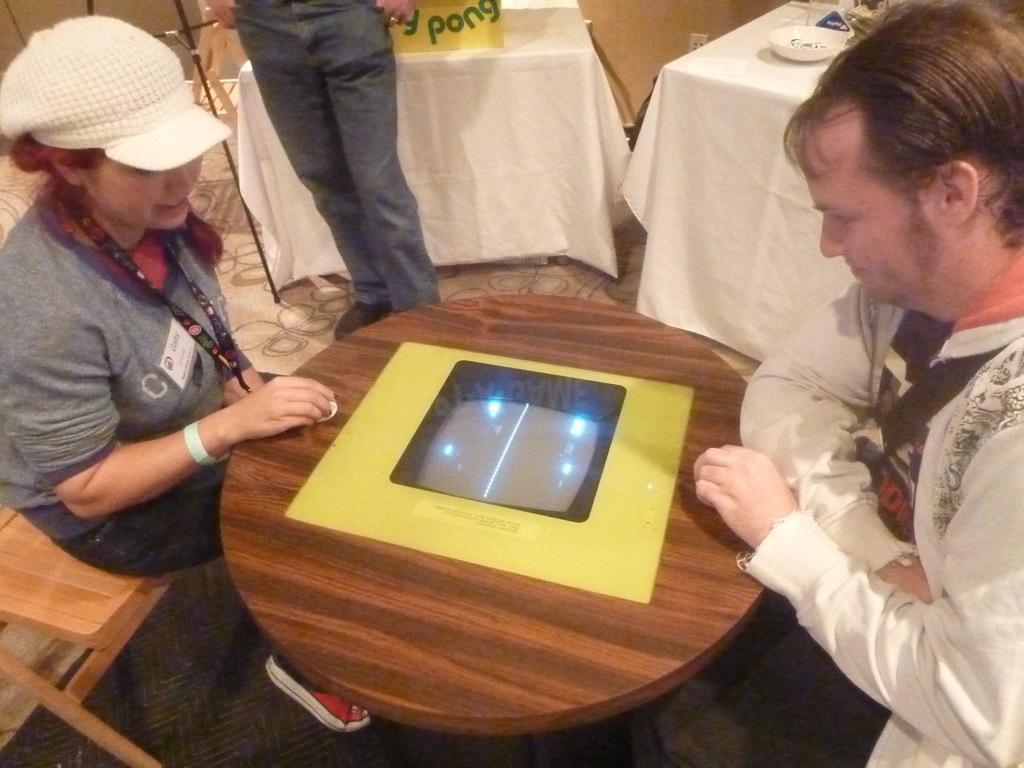Could you give a brief overview of what you see in this image? In this picture we can see three persons where two are sitting and playing on table and bedside to them man standing leaning to the table and on table we can see bowl, glass, poster. 